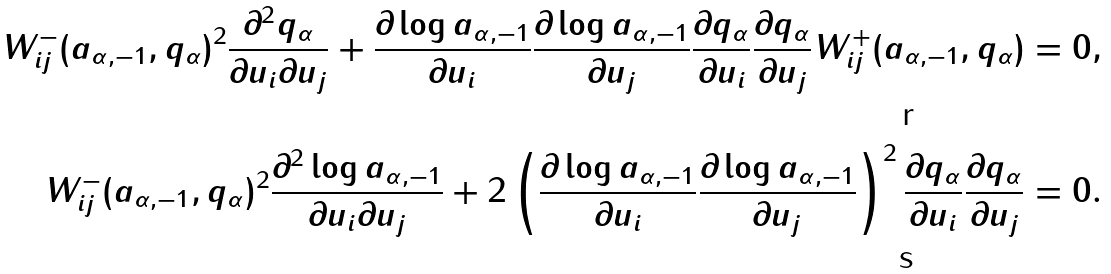<formula> <loc_0><loc_0><loc_500><loc_500>W _ { i j } ^ { - } ( a _ { \alpha , - 1 } , q _ { \alpha } ) ^ { 2 } \frac { \partial ^ { 2 } q _ { \alpha } } { \partial u _ { i } \partial u _ { j } } + \frac { \partial \log a _ { \alpha , - 1 } } { \partial u _ { i } } \frac { \partial \log a _ { \alpha , - 1 } } { \partial u _ { j } } \frac { \partial q _ { \alpha } } { \partial u _ { i } } \frac { \partial q _ { \alpha } } { \partial u _ { j } } W _ { i j } ^ { + } ( a _ { \alpha , - 1 } , q _ { \alpha } ) = 0 , \\ W _ { i j } ^ { - } ( a _ { \alpha , - 1 } , q _ { \alpha } ) ^ { 2 } \frac { \partial ^ { 2 } \log a _ { \alpha , - 1 } } { \partial u _ { i } \partial u _ { j } } + 2 \left ( \frac { \partial \log a _ { \alpha , - 1 } } { \partial u _ { i } } \frac { \partial \log a _ { \alpha , - 1 } } { \partial u _ { j } } \right ) ^ { 2 } \frac { \partial q _ { \alpha } } { \partial u _ { i } } \frac { \partial q _ { \alpha } } { \partial u _ { j } } = 0 .</formula> 